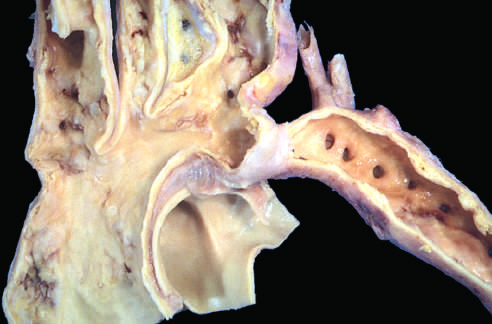what are perfused predominantly by way of dilated, tortuous collateral channels?
Answer the question using a single word or phrase. The lower extremities 